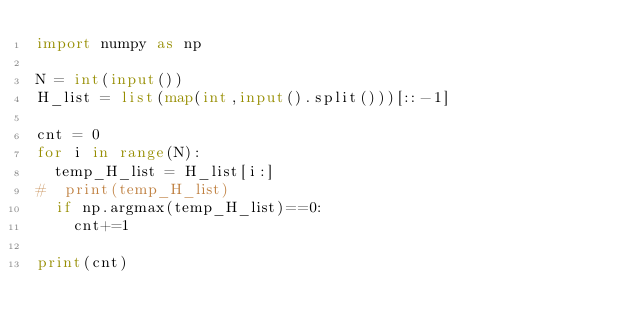Convert code to text. <code><loc_0><loc_0><loc_500><loc_500><_Python_>import numpy as np

N = int(input())
H_list = list(map(int,input().split()))[::-1]

cnt = 0
for i in range(N):
  temp_H_list = H_list[i:]
#  print(temp_H_list)
  if np.argmax(temp_H_list)==0:
    cnt+=1
    
print(cnt)</code> 